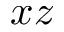Convert formula to latex. <formula><loc_0><loc_0><loc_500><loc_500>x z</formula> 